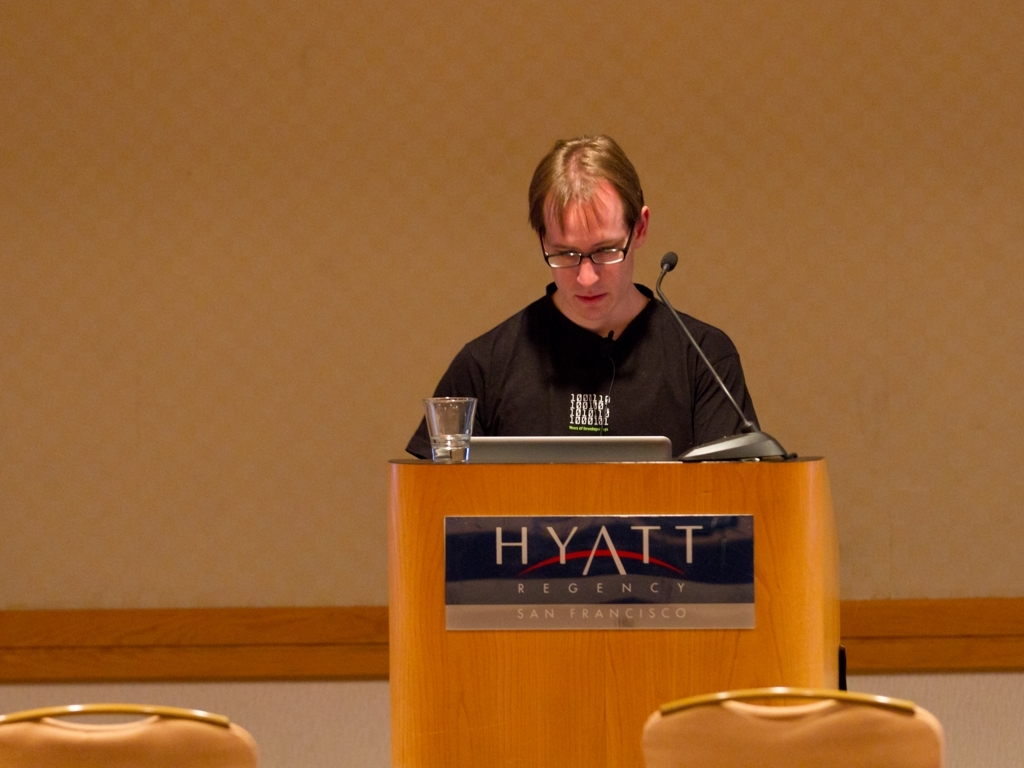Can the location where this event is happening be inferred from the image? Based on the signage on the lectern, the event is taking place at the Hyatt Regency in San Francisco, which is a common venue for conferences, seminars, and other professional gatherings. 